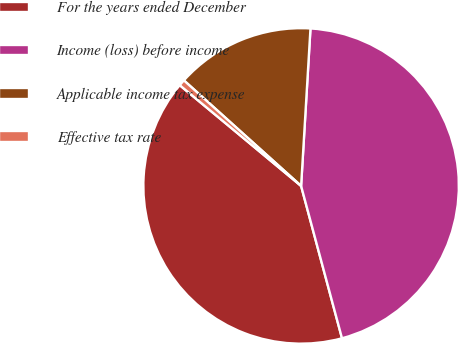<chart> <loc_0><loc_0><loc_500><loc_500><pie_chart><fcel>For the years ended December<fcel>Income (loss) before income<fcel>Applicable income tax expense<fcel>Effective tax rate<nl><fcel>40.2%<fcel>44.88%<fcel>14.28%<fcel>0.64%<nl></chart> 